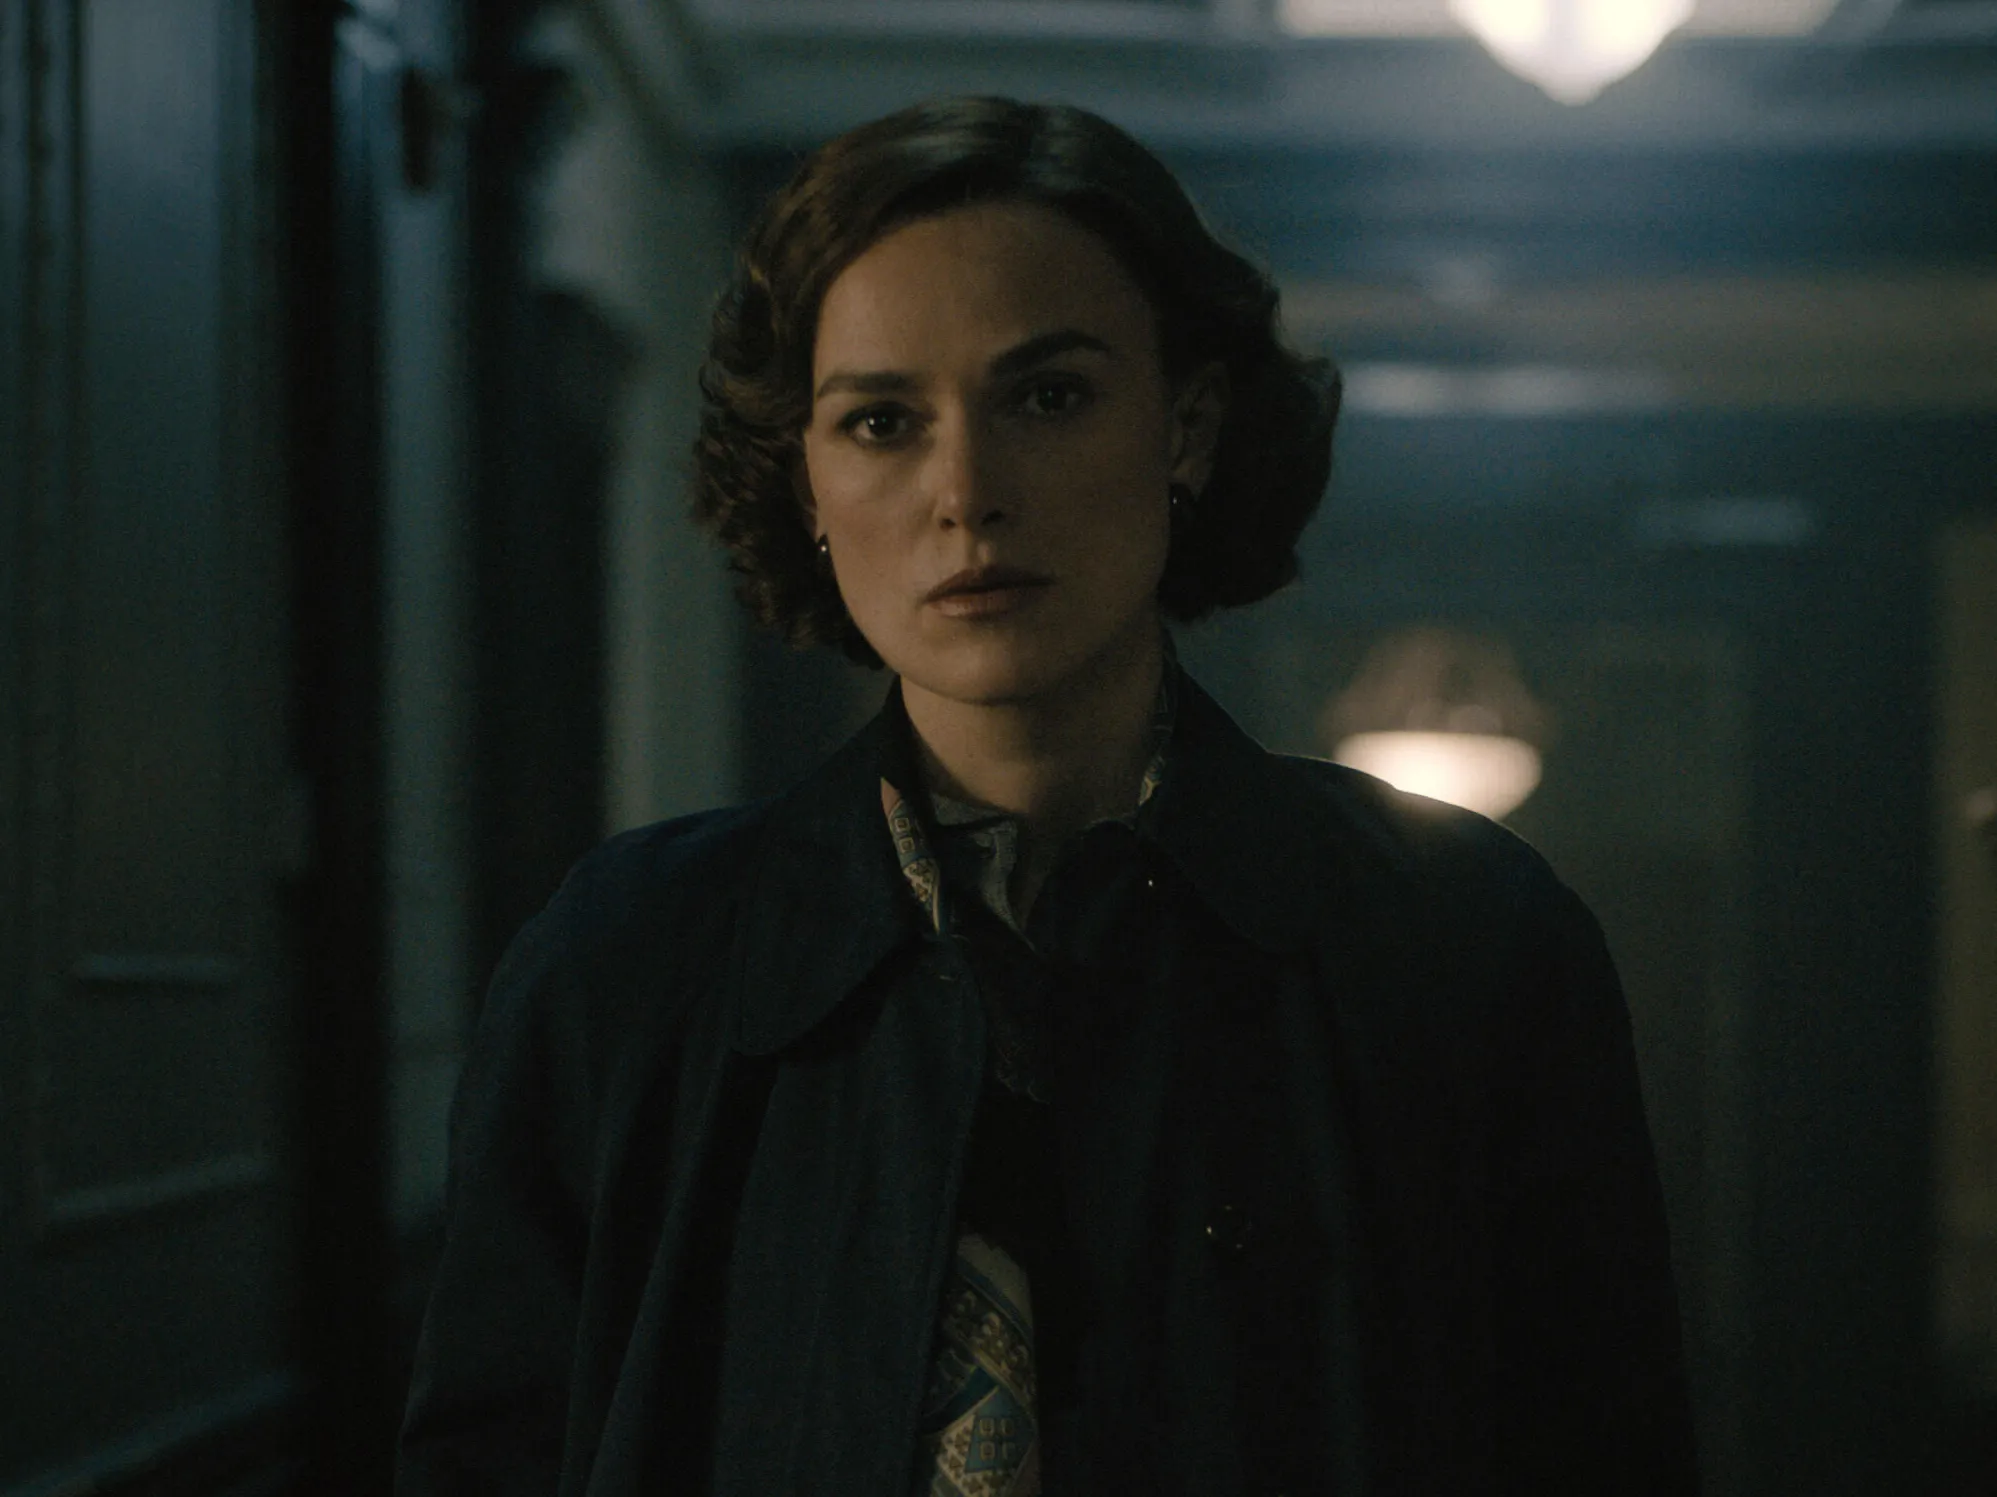If you could imagine this image as part of a larger story, what would that story be? In a broader narrative, this image represents a pivotal scene in a period drama set in the mid-20th century. The woman is an undercover spy working for a secretive organization during turbulent times. The dimly lit hallway is located in a grand, old manor that serves as the headquarters for clandestine meetings and covert operations. She's just overheard a conversation that could change the course of her mission and is now deep in thought, strategizing her next move. The story revolves around espionage, hidden identities, and complex moral decisions that define the era. What are some potential challenges she might face? Throughout her mission, she encounters numerous challenges such as evading capture by the enemy, deciphering encrypted messages, and dealing with the constant fear of betrayal from within her organization. Personal struggles might also come into play, including maintaining relationships under the guise of her false identity and coping with the ethical dilemmas of espionage. Every decision becomes a delicate balancing act between duty and morality, making her journey fraught with tension and suspense. 